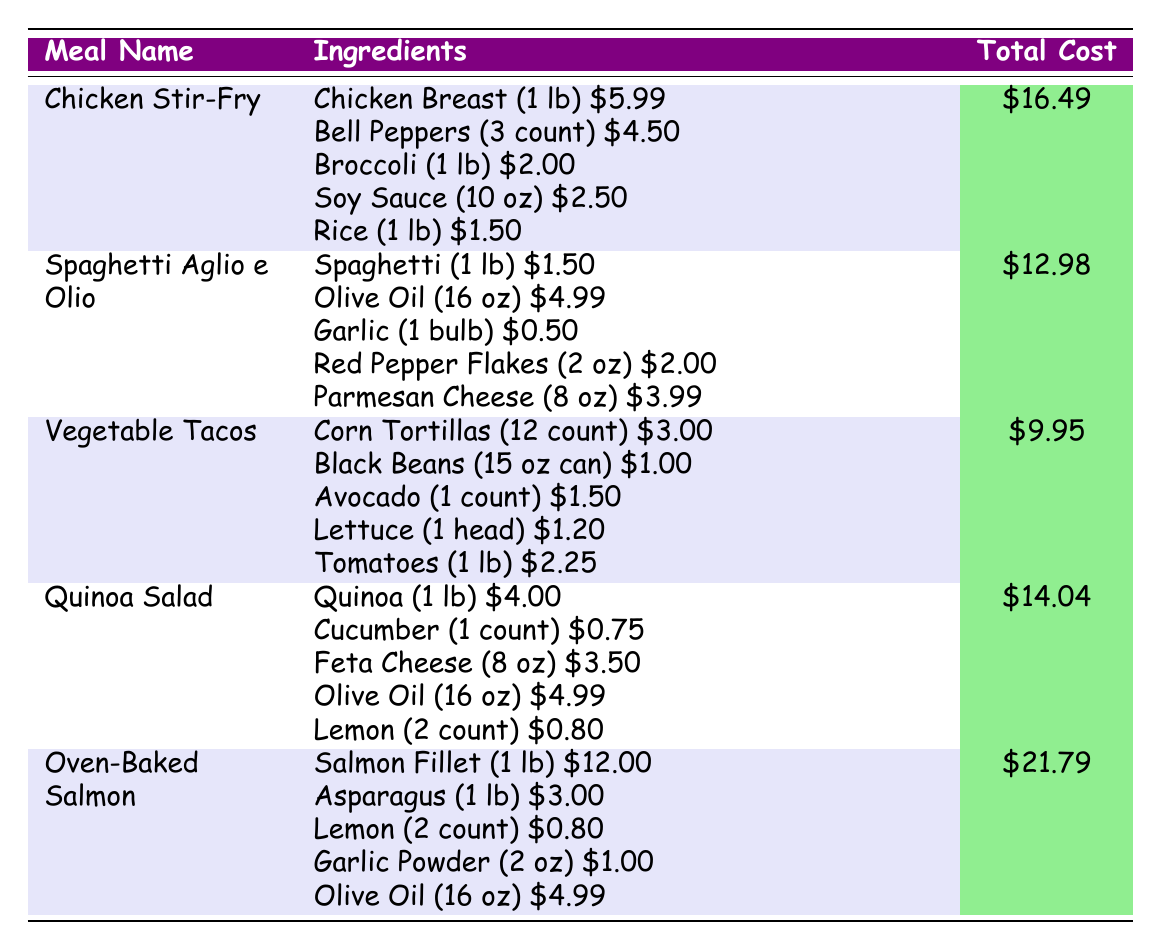What is the total cost of Chicken Stir-Fry? The total cost of Chicken Stir-Fry is listed directly in the table as $16.49.
Answer: $16.49 What are the ingredients for Vegetable Tacos? The ingredients for Vegetable Tacos are Corn Tortillas, Black Beans, Avocado, Lettuce, and Tomatoes, with respective costs.
Answer: Corn Tortillas, Black Beans, Avocado, Lettuce, Tomatoes How much does a pound of Salmon Fillet cost? The cost of Salmon Fillet (1 lb) is directly shown in the table as $12.00.
Answer: $12.00 What meal has the highest total cost? By comparing the total costs listed, Oven-Baked Salmon has the highest total cost of $21.79.
Answer: Oven-Baked Salmon What is the total cost of ingredients for Quinoa Salad? The total cost of Quinoa Salad is given directly in the table as $14.04.
Answer: $14.04 What is the average total cost of all the meals listed? To find the average, sum the total costs of all meals: $16.49 + $12.98 + $9.95 + $14.04 + $21.79 = $75.25. Then divide by the number of meals (5): $75.25 / 5 = $15.05.
Answer: $15.05 Does Spaghetti Aglio e Olio cost less than $15? The total cost of Spaghetti Aglio e Olio is $12.98, which is less than $15.
Answer: Yes Which meal has a total cost that is less than both Chicken Stir-Fry and Quinoa Salad? Chicken Stir-Fry costs $16.49 and Quinoa Salad costs $14.04. The only meal costing less than both is Vegetable Tacos at $9.95.
Answer: Vegetable Tacos What is the difference in total cost between Oven-Baked Salmon and Vegetable Tacos? The total cost of Oven-Baked Salmon is $21.79 and Vegetable Tacos is $9.95. The difference is $21.79 - $9.95 = $11.84.
Answer: $11.84 How much do all the ingredients for Spaghetti Aglio e Olio cost combined? The combined cost of ingredients for Spaghetti Aglio e Olio is calculated by adding each ingredient: $1.50 (Spaghetti) + $4.99 (Olive Oil) + $0.50 (Garlic) + $2.00 (Red Pepper Flakes) + $3.99 (Parmesan Cheese) = $13.98.
Answer: $13.98 